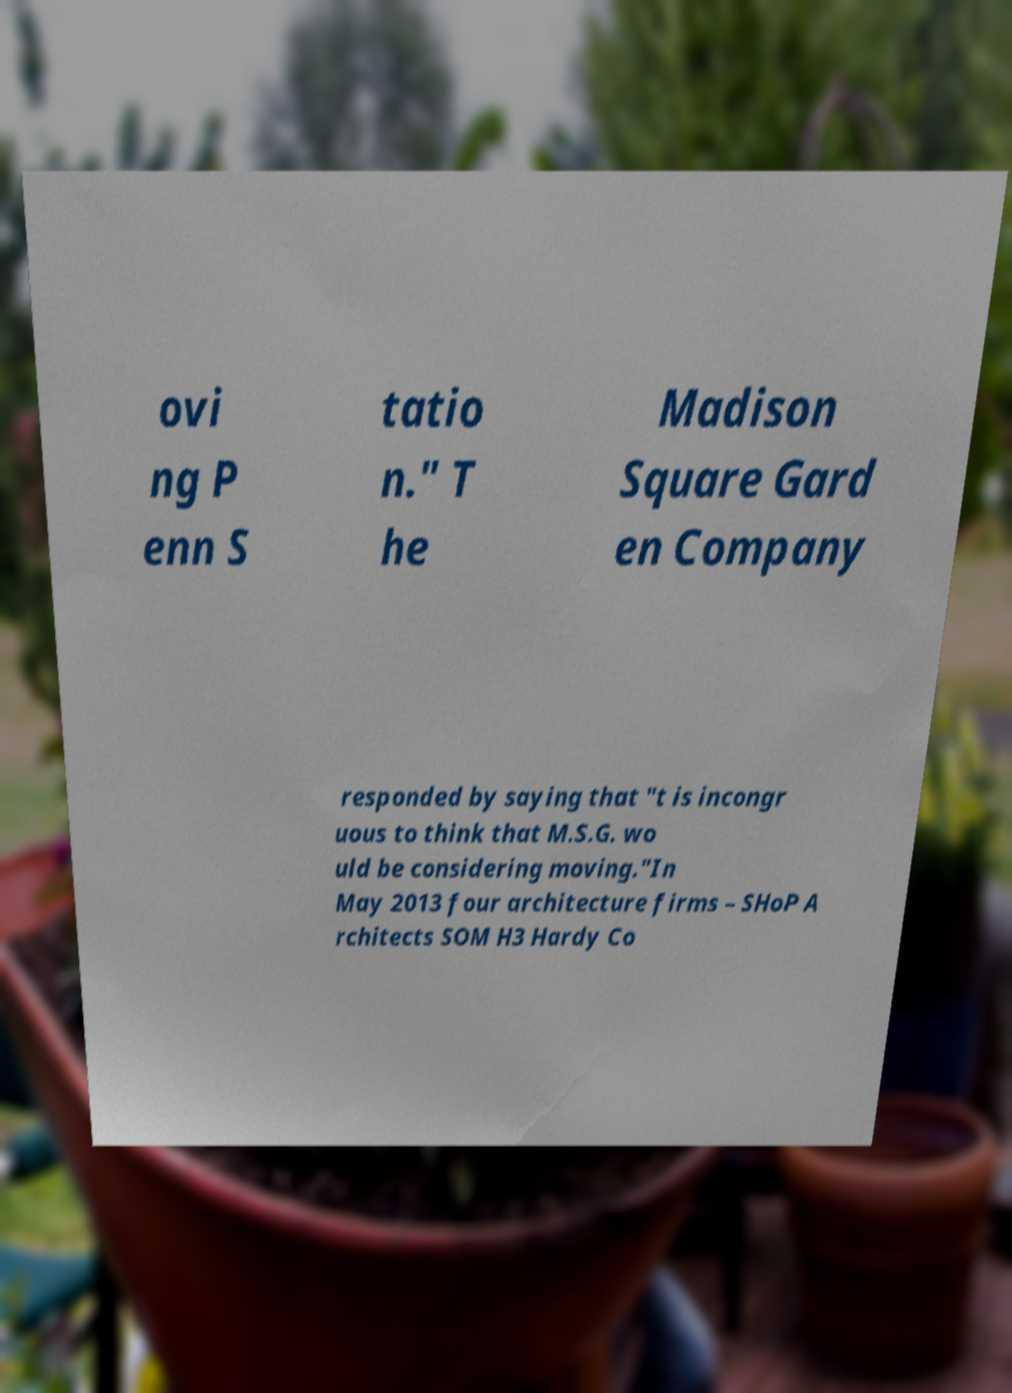Can you accurately transcribe the text from the provided image for me? ovi ng P enn S tatio n." T he Madison Square Gard en Company responded by saying that "t is incongr uous to think that M.S.G. wo uld be considering moving."In May 2013 four architecture firms – SHoP A rchitects SOM H3 Hardy Co 